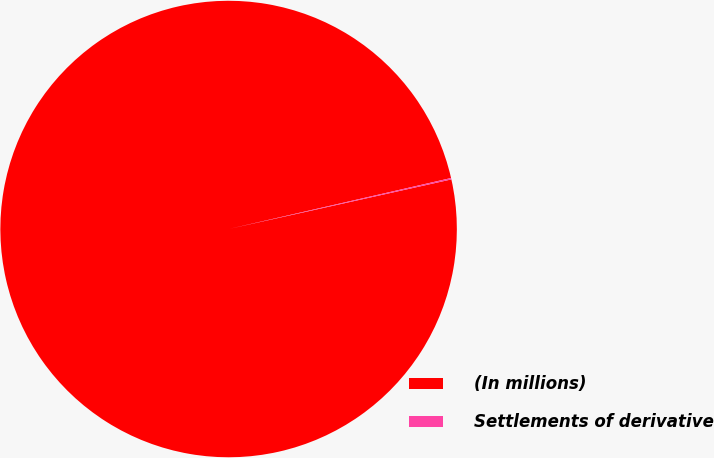Convert chart to OTSL. <chart><loc_0><loc_0><loc_500><loc_500><pie_chart><fcel>(In millions)<fcel>Settlements of derivative<nl><fcel>99.9%<fcel>0.1%<nl></chart> 